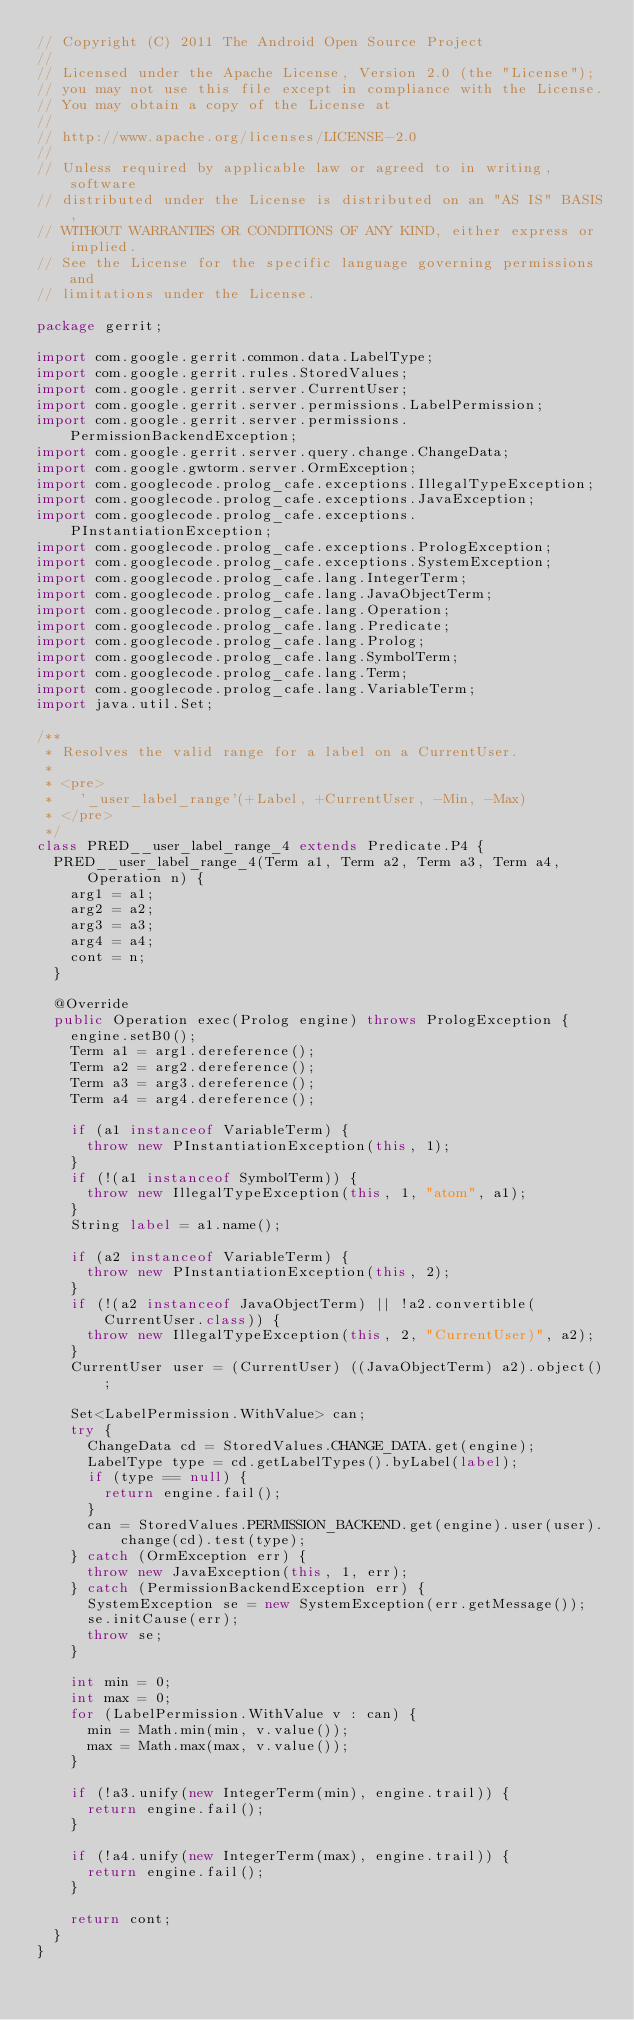Convert code to text. <code><loc_0><loc_0><loc_500><loc_500><_Java_>// Copyright (C) 2011 The Android Open Source Project
//
// Licensed under the Apache License, Version 2.0 (the "License");
// you may not use this file except in compliance with the License.
// You may obtain a copy of the License at
//
// http://www.apache.org/licenses/LICENSE-2.0
//
// Unless required by applicable law or agreed to in writing, software
// distributed under the License is distributed on an "AS IS" BASIS,
// WITHOUT WARRANTIES OR CONDITIONS OF ANY KIND, either express or implied.
// See the License for the specific language governing permissions and
// limitations under the License.

package gerrit;

import com.google.gerrit.common.data.LabelType;
import com.google.gerrit.rules.StoredValues;
import com.google.gerrit.server.CurrentUser;
import com.google.gerrit.server.permissions.LabelPermission;
import com.google.gerrit.server.permissions.PermissionBackendException;
import com.google.gerrit.server.query.change.ChangeData;
import com.google.gwtorm.server.OrmException;
import com.googlecode.prolog_cafe.exceptions.IllegalTypeException;
import com.googlecode.prolog_cafe.exceptions.JavaException;
import com.googlecode.prolog_cafe.exceptions.PInstantiationException;
import com.googlecode.prolog_cafe.exceptions.PrologException;
import com.googlecode.prolog_cafe.exceptions.SystemException;
import com.googlecode.prolog_cafe.lang.IntegerTerm;
import com.googlecode.prolog_cafe.lang.JavaObjectTerm;
import com.googlecode.prolog_cafe.lang.Operation;
import com.googlecode.prolog_cafe.lang.Predicate;
import com.googlecode.prolog_cafe.lang.Prolog;
import com.googlecode.prolog_cafe.lang.SymbolTerm;
import com.googlecode.prolog_cafe.lang.Term;
import com.googlecode.prolog_cafe.lang.VariableTerm;
import java.util.Set;

/**
 * Resolves the valid range for a label on a CurrentUser.
 *
 * <pre>
 *   '_user_label_range'(+Label, +CurrentUser, -Min, -Max)
 * </pre>
 */
class PRED__user_label_range_4 extends Predicate.P4 {
  PRED__user_label_range_4(Term a1, Term a2, Term a3, Term a4, Operation n) {
    arg1 = a1;
    arg2 = a2;
    arg3 = a3;
    arg4 = a4;
    cont = n;
  }

  @Override
  public Operation exec(Prolog engine) throws PrologException {
    engine.setB0();
    Term a1 = arg1.dereference();
    Term a2 = arg2.dereference();
    Term a3 = arg3.dereference();
    Term a4 = arg4.dereference();

    if (a1 instanceof VariableTerm) {
      throw new PInstantiationException(this, 1);
    }
    if (!(a1 instanceof SymbolTerm)) {
      throw new IllegalTypeException(this, 1, "atom", a1);
    }
    String label = a1.name();

    if (a2 instanceof VariableTerm) {
      throw new PInstantiationException(this, 2);
    }
    if (!(a2 instanceof JavaObjectTerm) || !a2.convertible(CurrentUser.class)) {
      throw new IllegalTypeException(this, 2, "CurrentUser)", a2);
    }
    CurrentUser user = (CurrentUser) ((JavaObjectTerm) a2).object();

    Set<LabelPermission.WithValue> can;
    try {
      ChangeData cd = StoredValues.CHANGE_DATA.get(engine);
      LabelType type = cd.getLabelTypes().byLabel(label);
      if (type == null) {
        return engine.fail();
      }
      can = StoredValues.PERMISSION_BACKEND.get(engine).user(user).change(cd).test(type);
    } catch (OrmException err) {
      throw new JavaException(this, 1, err);
    } catch (PermissionBackendException err) {
      SystemException se = new SystemException(err.getMessage());
      se.initCause(err);
      throw se;
    }

    int min = 0;
    int max = 0;
    for (LabelPermission.WithValue v : can) {
      min = Math.min(min, v.value());
      max = Math.max(max, v.value());
    }

    if (!a3.unify(new IntegerTerm(min), engine.trail)) {
      return engine.fail();
    }

    if (!a4.unify(new IntegerTerm(max), engine.trail)) {
      return engine.fail();
    }

    return cont;
  }
}
</code> 